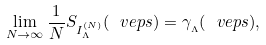<formula> <loc_0><loc_0><loc_500><loc_500>\lim _ { N \to \infty } { \frac { 1 } { N } } S _ { { I } ^ { ( N ) } _ { \Lambda } } ( \ v e p s ) = \gamma _ { _ { \Lambda } } ( \ v e p s ) ,</formula> 